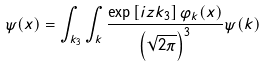Convert formula to latex. <formula><loc_0><loc_0><loc_500><loc_500>\psi ( x ) = \int _ { k _ { 3 } } \int _ { k } \frac { \exp \left [ i z k _ { 3 } \right ] \varphi _ { k } ( x ) } { \left ( \sqrt { 2 \pi } \right ) ^ { 3 } } \psi ( k )</formula> 